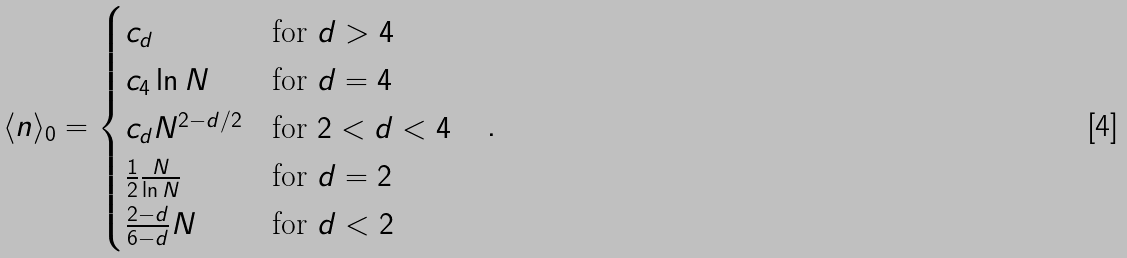<formula> <loc_0><loc_0><loc_500><loc_500>\langle n \rangle _ { 0 } = \begin{cases} c _ { d } & \text {for $d>4$} \\ c _ { 4 } \ln N & \text {for $d=4$} \\ c _ { d } N ^ { 2 - d / 2 } & \text {for $2<d<4$} \\ \frac { 1 } { 2 } \frac { N } { \ln N } & \text {for $d=2$} \\ \frac { 2 - d } { 6 - d } N & \text {for $d<2$} \end{cases} \quad .</formula> 